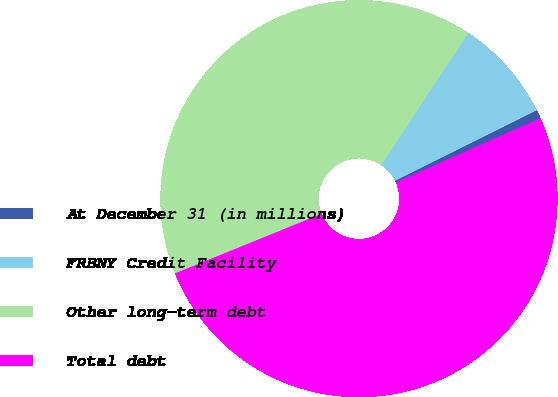Convert chart to OTSL. <chart><loc_0><loc_0><loc_500><loc_500><pie_chart><fcel>At December 31 (in millions)<fcel>FRBNY Credit Facility<fcel>Other long-term debt<fcel>Total debt<nl><fcel>0.72%<fcel>8.36%<fcel>40.43%<fcel>50.49%<nl></chart> 